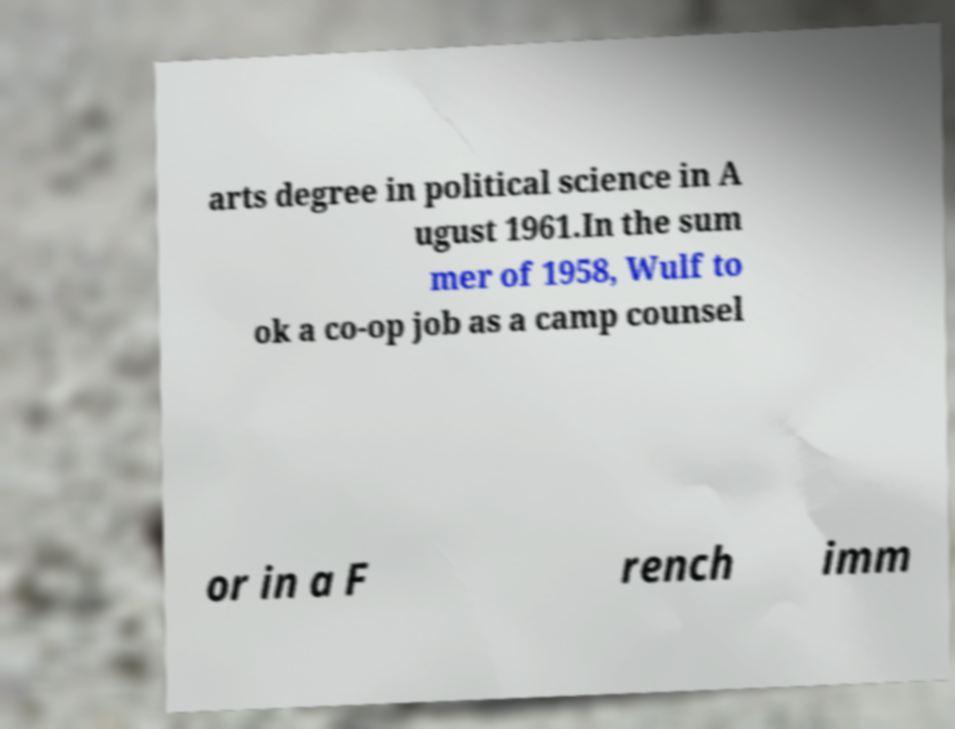Could you extract and type out the text from this image? arts degree in political science in A ugust 1961.In the sum mer of 1958, Wulf to ok a co-op job as a camp counsel or in a F rench imm 